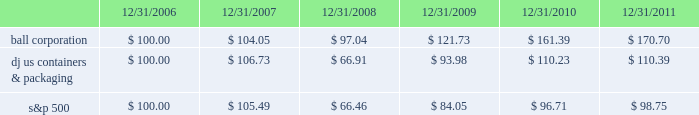Shareholder return performance the line graph below compares the annual percentage change in ball corporation fffds cumulative total shareholder return on its common stock with the cumulative total return of the dow jones containers & packaging index and the s&p composite 500 stock index for the five-year period ended december 31 , 2011 .
It assumes $ 100 was invested on december 31 , 2006 , and that all dividends were reinvested .
The dow jones containers & packaging index total return has been weighted by market capitalization .
Total return to stockholders ( assumes $ 100 investment on 12/31/06 ) total return analysis .
Copyright a9 2012 standard & poor fffds , a division of the mcgraw-hill companies inc .
All rights reserved .
( www.researchdatagroup.com/s&p.htm ) copyright a9 2012 dow jones & company .
All rights reserved. .
What was the five year percentage return on ball corporation stock? 
Computations: (170.70 / 100.00)
Answer: 1.707. 